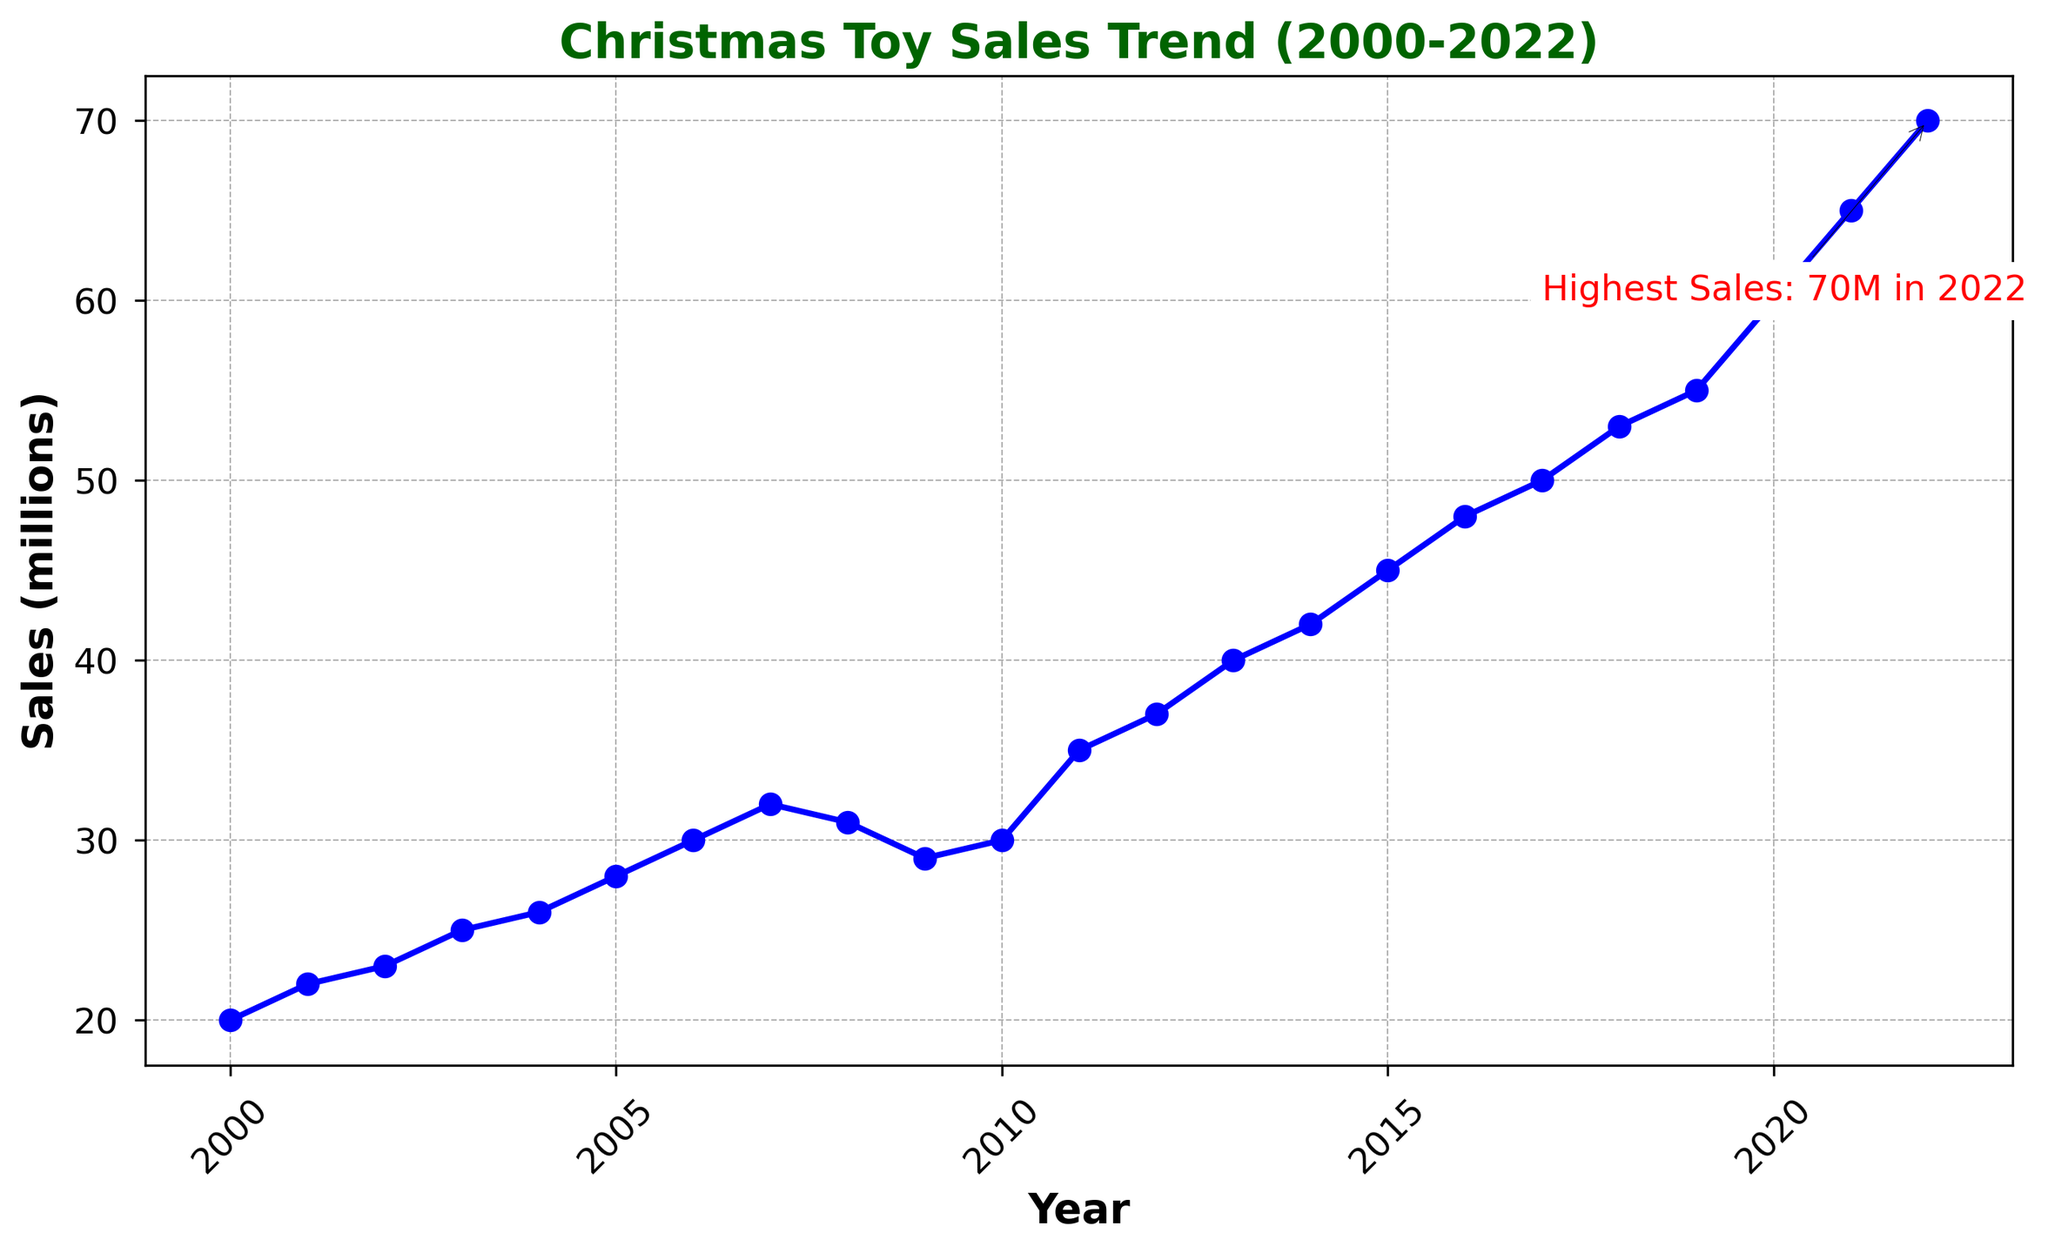Which year saw the highest Christmas toy sales? The annotation on the plot indicates that the highest sales were in 2022. The label "Highest Sales: 70M in 2022" confirms this.
Answer: 2022 What was the difference in Christmas toy sales between 2020 and 2021? From the plot, the sales were 60 million in 2020 and 65 million in 2021. Subtracting these values gives 65 - 60 = 5 million.
Answer: 5 million How did Christmas toy sales in 2009 compare to 2008? Sales in 2008 were 31 million and in 2009 they dropped to 29 million, showing a decrease.
Answer: Decreased What's the average Christmas toy sales from 2010 to 2015? The sales values from 2010 to 2015 are 30, 35, 37, 40, 42, and 45 million. Summing these gives 30 + 35 + 37 + 40 + 42 + 45 = 229 million, and dividing by 6 gives 229 / 6 ≈ 38.17 million.
Answer: 38.17 million Between which years did the Christmas toy sales see the largest growth? By observing the plot, the largest year-over-year growth appears between 2019 (55 million) and 2020 (60 million), an increase of 5 million.
Answer: 2019-2020 What is the overall trend in Christmas toy sales from 2000 to 2022? The overall trend shows a steady increase in sales from 20 million in 2000 to 70 million in 2022, indicating a general upward trend.
Answer: Upward trend In which year did the sales first exceed 40 million? The plot shows that in 2013, the sales were 40 million. The next year, 2014, shows sales of 42 million, exceeding 40 million for the first time.
Answer: 2014 What is the average growth in Christmas toy sales per year from 2000 to 2022? The difference between 2022 (70 million) and 2000 (20 million) sales is 70 - 20 = 50 million over 22 years. Dividing the total growth by the number of years gives 50 / 22 ≈ 2.27 million per year.
Answer: 2.27 million per year Which year experienced a slight dip in sales after a continuous rise? The plot shows that after a rise in sales from 2007 (32 million) to 2008 (31 million), there was a slight dip in 2009 to 29 million.
Answer: 2009 